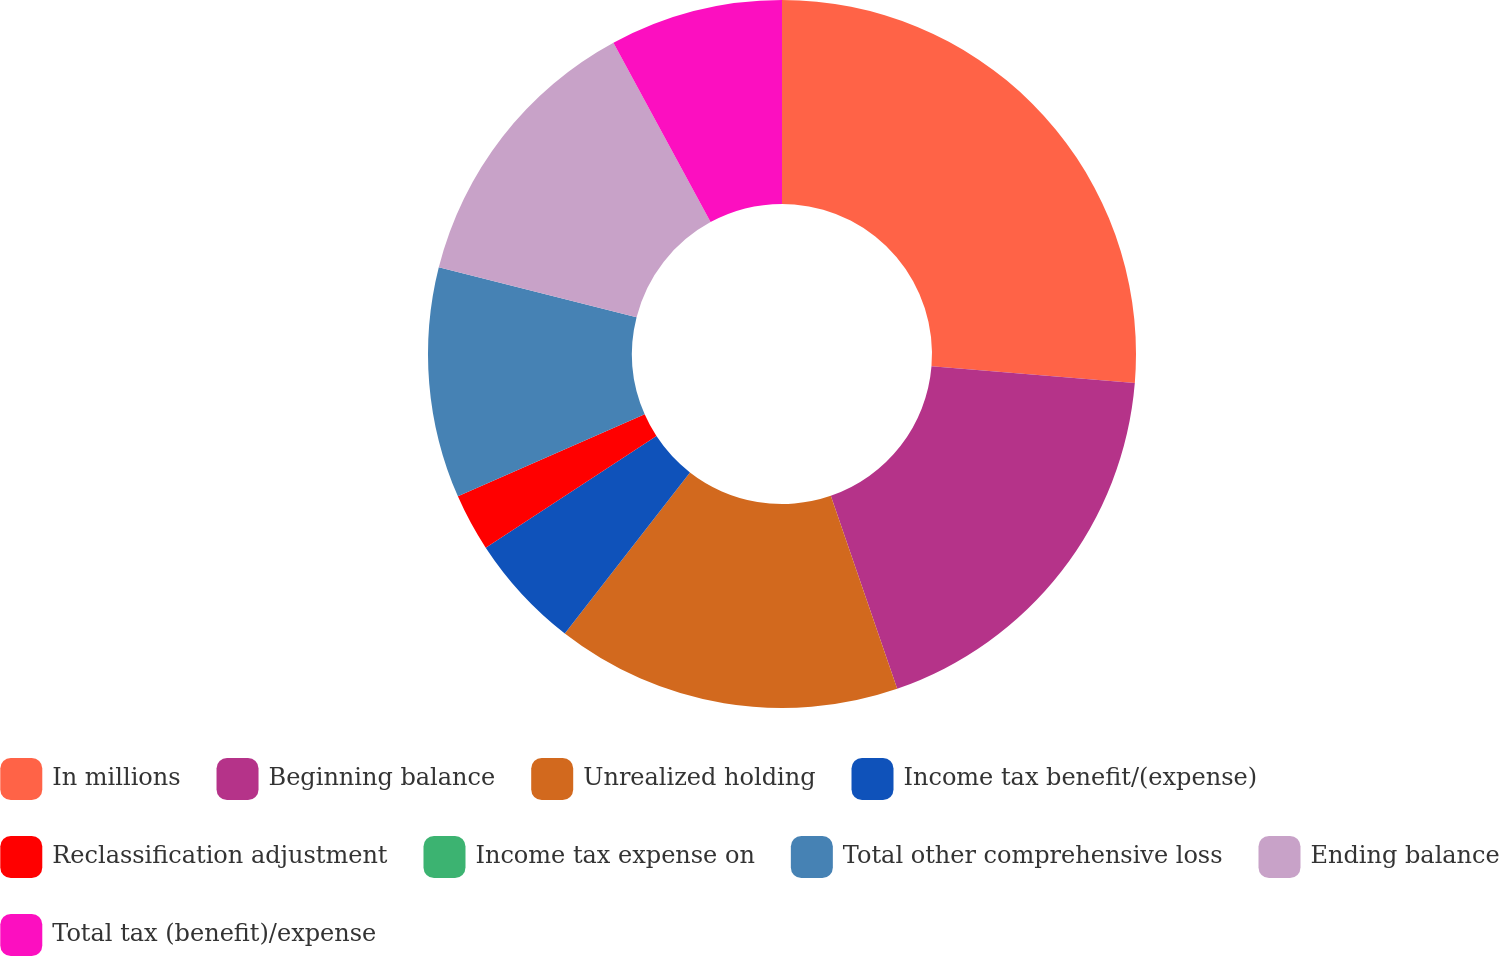Convert chart. <chart><loc_0><loc_0><loc_500><loc_500><pie_chart><fcel>In millions<fcel>Beginning balance<fcel>Unrealized holding<fcel>Income tax benefit/(expense)<fcel>Reclassification adjustment<fcel>Income tax expense on<fcel>Total other comprehensive loss<fcel>Ending balance<fcel>Total tax (benefit)/expense<nl><fcel>26.31%<fcel>18.42%<fcel>15.79%<fcel>5.27%<fcel>2.63%<fcel>0.0%<fcel>10.53%<fcel>13.16%<fcel>7.9%<nl></chart> 